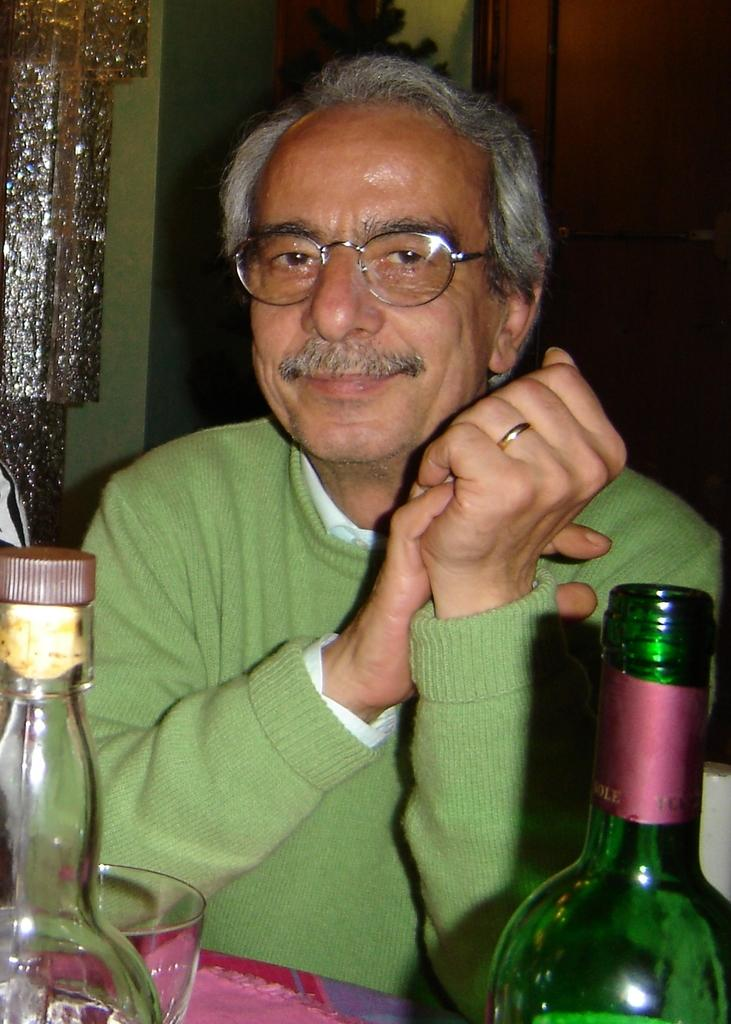Who is present in the image? There is a man in the image. What is the man doing in the image? The man is sitting. What objects can be seen on the table in the image? There are wine bottles and a glass on the table. What type of furniture is present in the bedroom in the image? There is no furniture or bedroom present in the image; it features a man sitting and objects on a table. What medical advice does the doctor provide in the image? There is no doctor present in the image, so no medical advice can be given. 